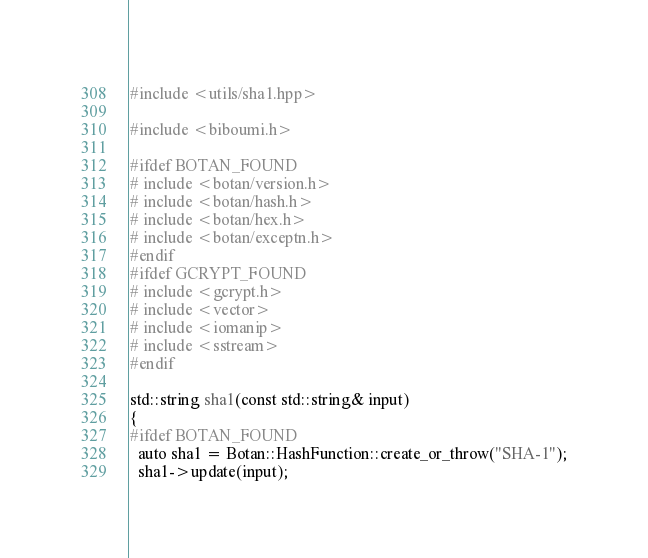<code> <loc_0><loc_0><loc_500><loc_500><_C++_>#include <utils/sha1.hpp>

#include <biboumi.h>

#ifdef BOTAN_FOUND
# include <botan/version.h>
# include <botan/hash.h>
# include <botan/hex.h>
# include <botan/exceptn.h>
#endif
#ifdef GCRYPT_FOUND
# include <gcrypt.h>
# include <vector>
# include <iomanip>
# include <sstream>
#endif

std::string sha1(const std::string& input)
{
#ifdef BOTAN_FOUND
  auto sha1 = Botan::HashFunction::create_or_throw("SHA-1");
  sha1->update(input);</code> 